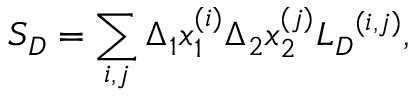Convert formula to latex. <formula><loc_0><loc_0><loc_500><loc_500>{ S } _ { D } = \sum _ { i , j } \Delta _ { 1 } x _ { 1 } ^ { ( i ) } \Delta _ { 2 } x _ { 2 } ^ { ( j ) } { { L } _ { D } } ^ { ( i , j ) } ,</formula> 